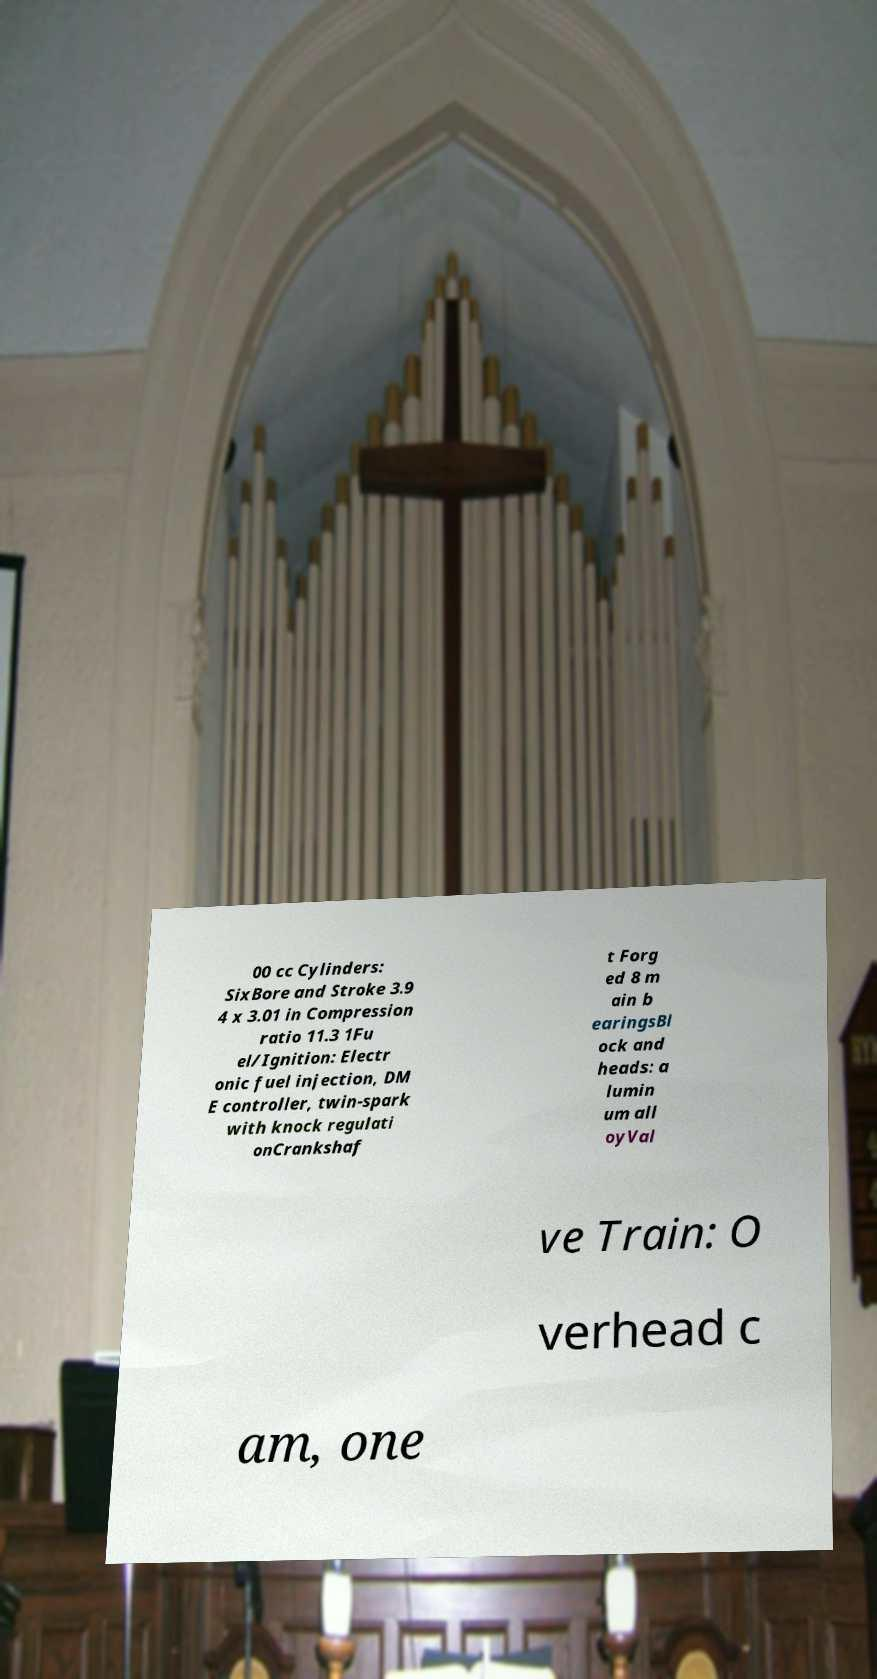What messages or text are displayed in this image? I need them in a readable, typed format. 00 cc Cylinders: SixBore and Stroke 3.9 4 x 3.01 in Compression ratio 11.3 1Fu el/Ignition: Electr onic fuel injection, DM E controller, twin-spark with knock regulati onCrankshaf t Forg ed 8 m ain b earingsBl ock and heads: a lumin um all oyVal ve Train: O verhead c am, one 